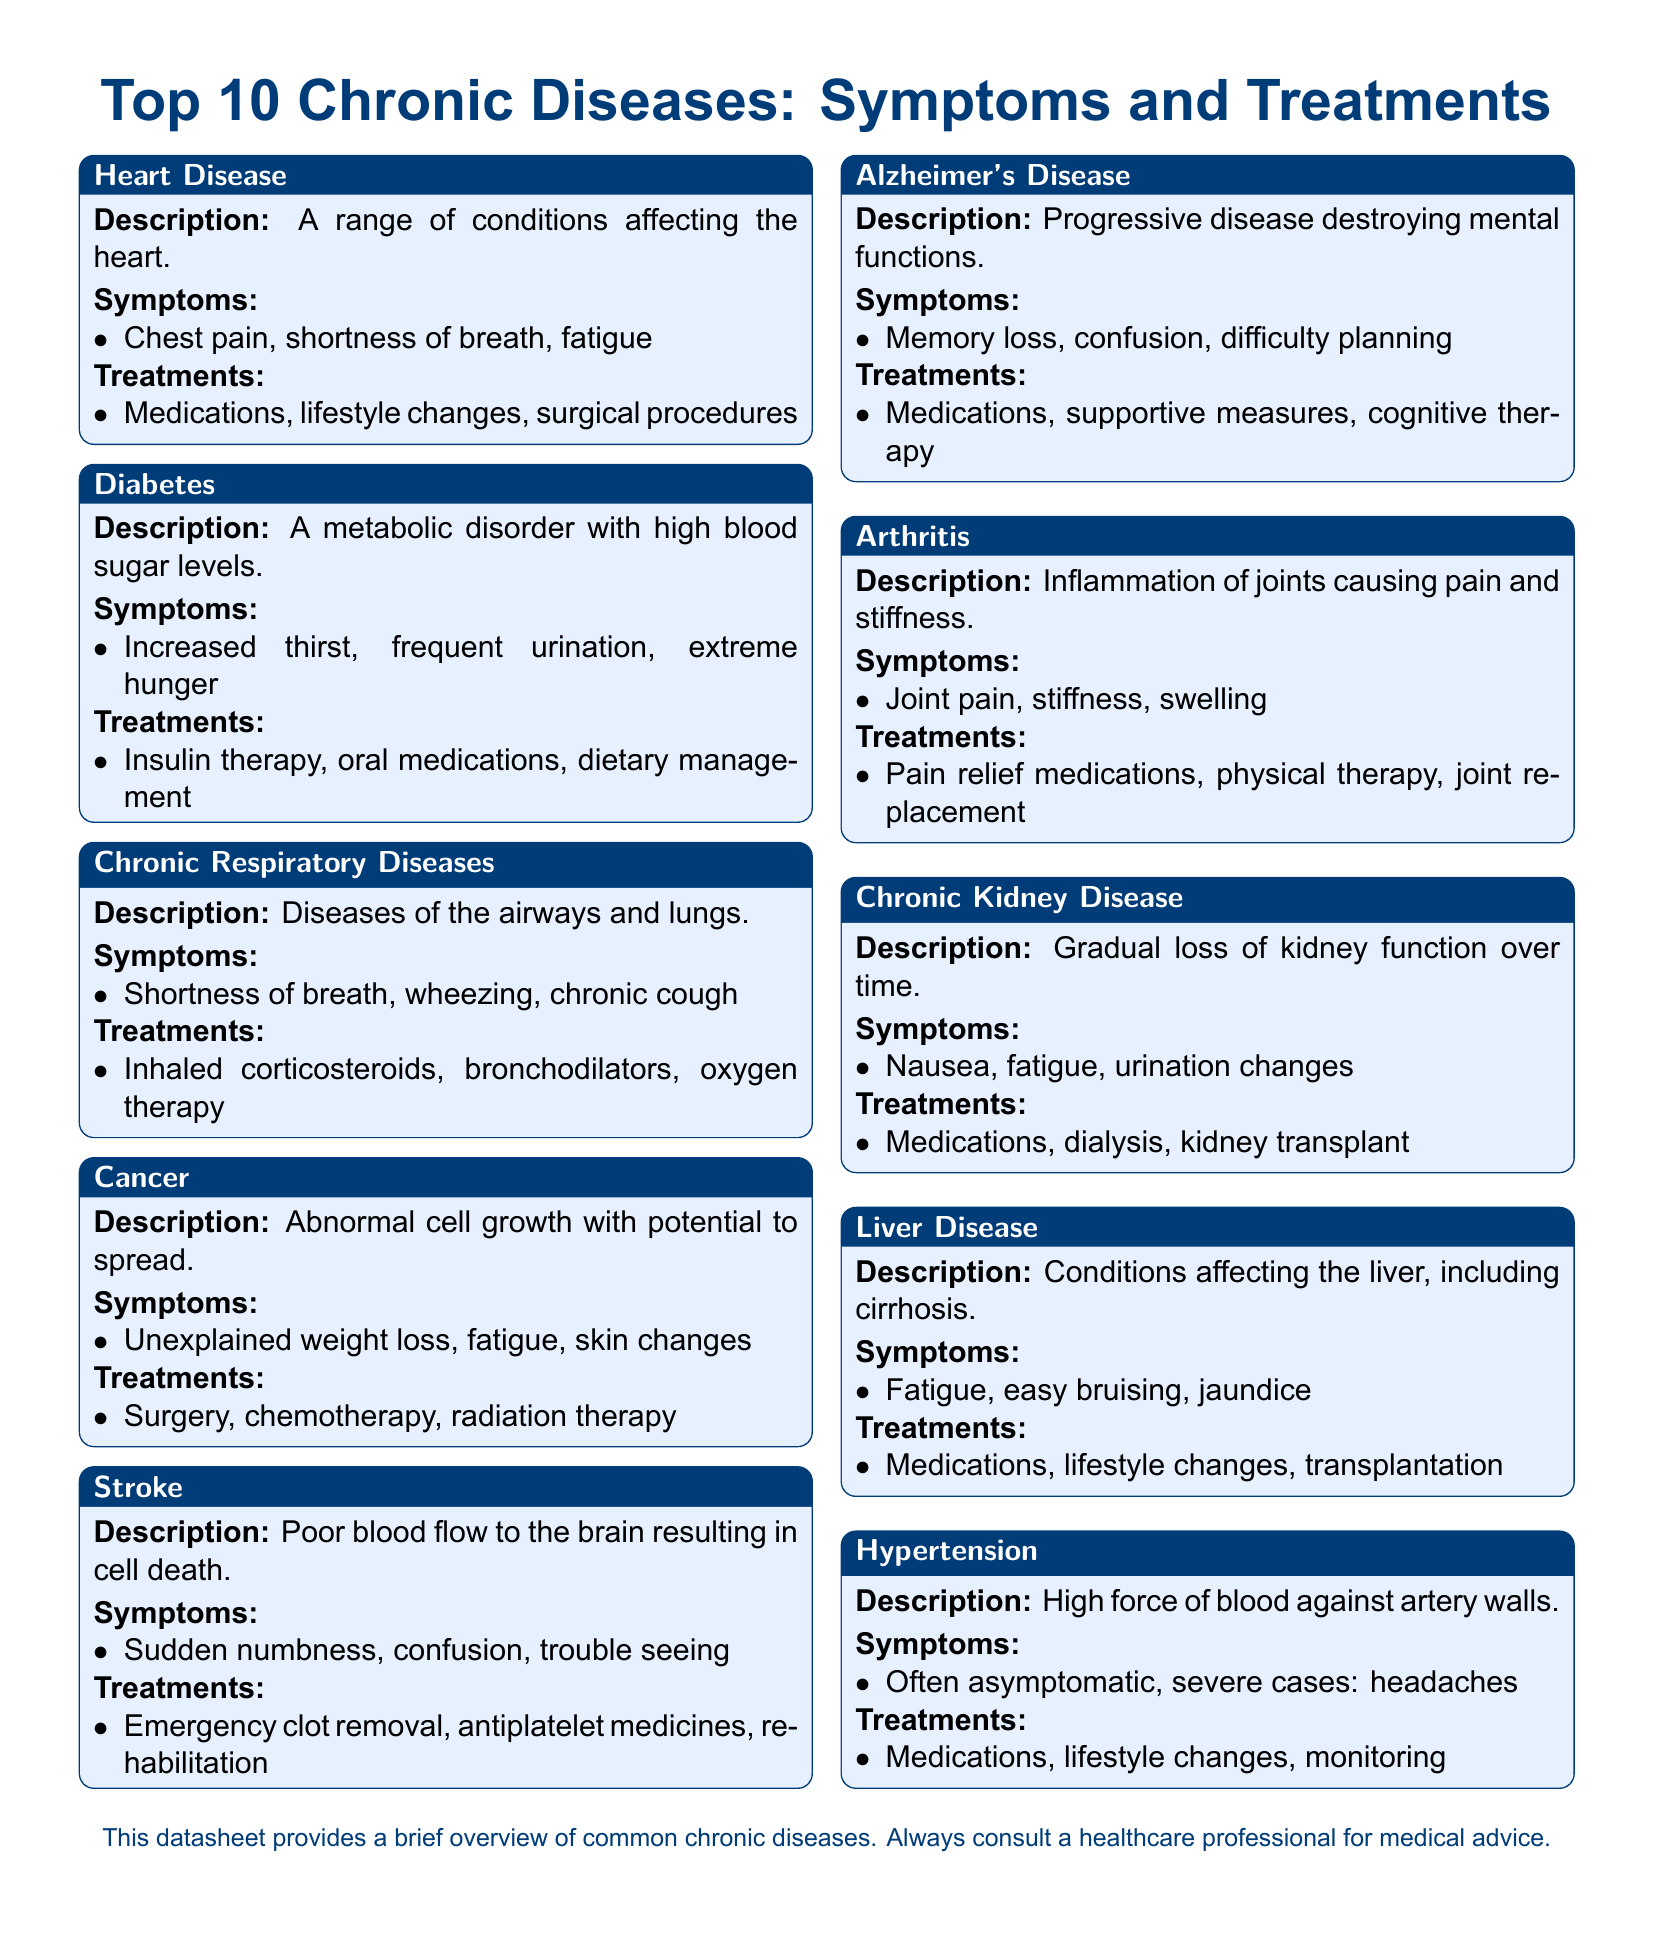What is a common symptom of Heart Disease? Heart Disease is associated with symptoms such as chest pain, shortness of breath, and fatigue.
Answer: Chest pain What disease is characterized by high blood sugar levels? The chronic disease that describes high blood sugar levels is Diabetes.
Answer: Diabetes What treatment options are available for Chronic Kidney Disease? Treatments for Chronic Kidney Disease include medications, dialysis, and kidney transplant.
Answer: Medications, dialysis, kidney transplant Which disease involves poor blood flow to the brain? Stroke is defined by poor blood flow to the brain, which can lead to cell death.
Answer: Stroke What is a common symptom of Arthritis? Common symptoms of Arthritis include joint pain, stiffness, and swelling.
Answer: Joint pain Name one treatment for Alzheimer's Disease. Treatments for Alzheimer's Disease include medications, supportive measures, and cognitive therapy.
Answer: Medications What condition may cause easy bruising? Liver Disease may lead to symptoms like easy bruising among others.
Answer: Liver Disease How many diseases are listed in the document? The document specifies a total of 10 chronic diseases.
Answer: 10 What is often a symptom of Hypertension? Hypertension can frequently be asymptomatic, but in severe cases, it might cause headaches.
Answer: Headaches 